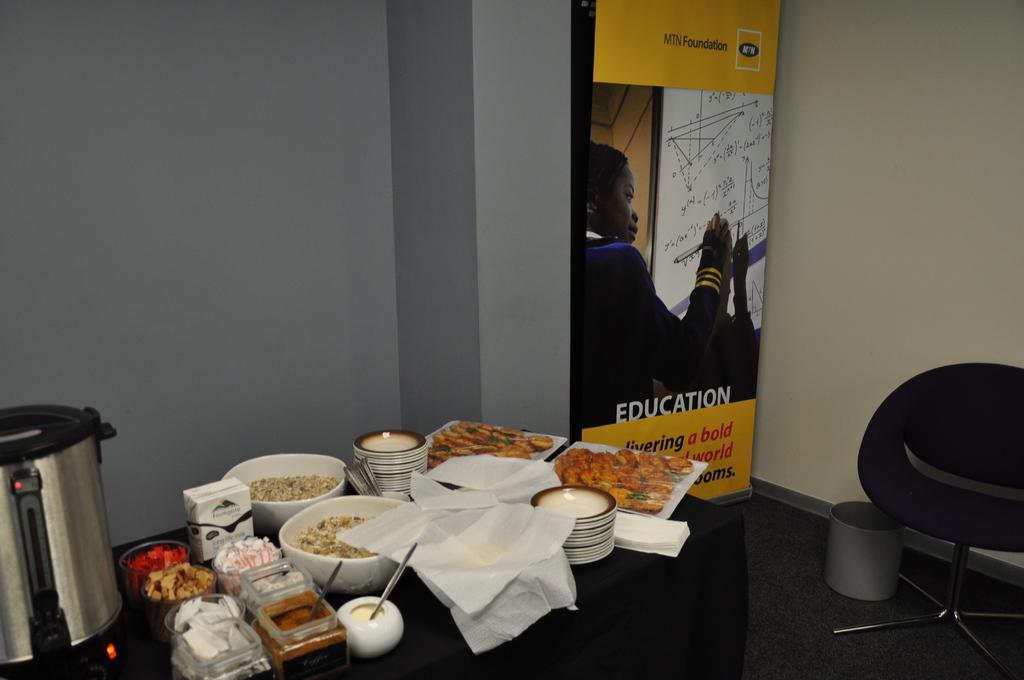Could you give a brief overview of what you see in this image? In this image we can see the table which is covered with the black color cloth. On the table we can see the kitchen appliance, also food items, spoons, tissues, plates and also a packet. In the background we can see the plain wall and also the banner with text and also the image. On the right there is a chair and also an object on the floor. 